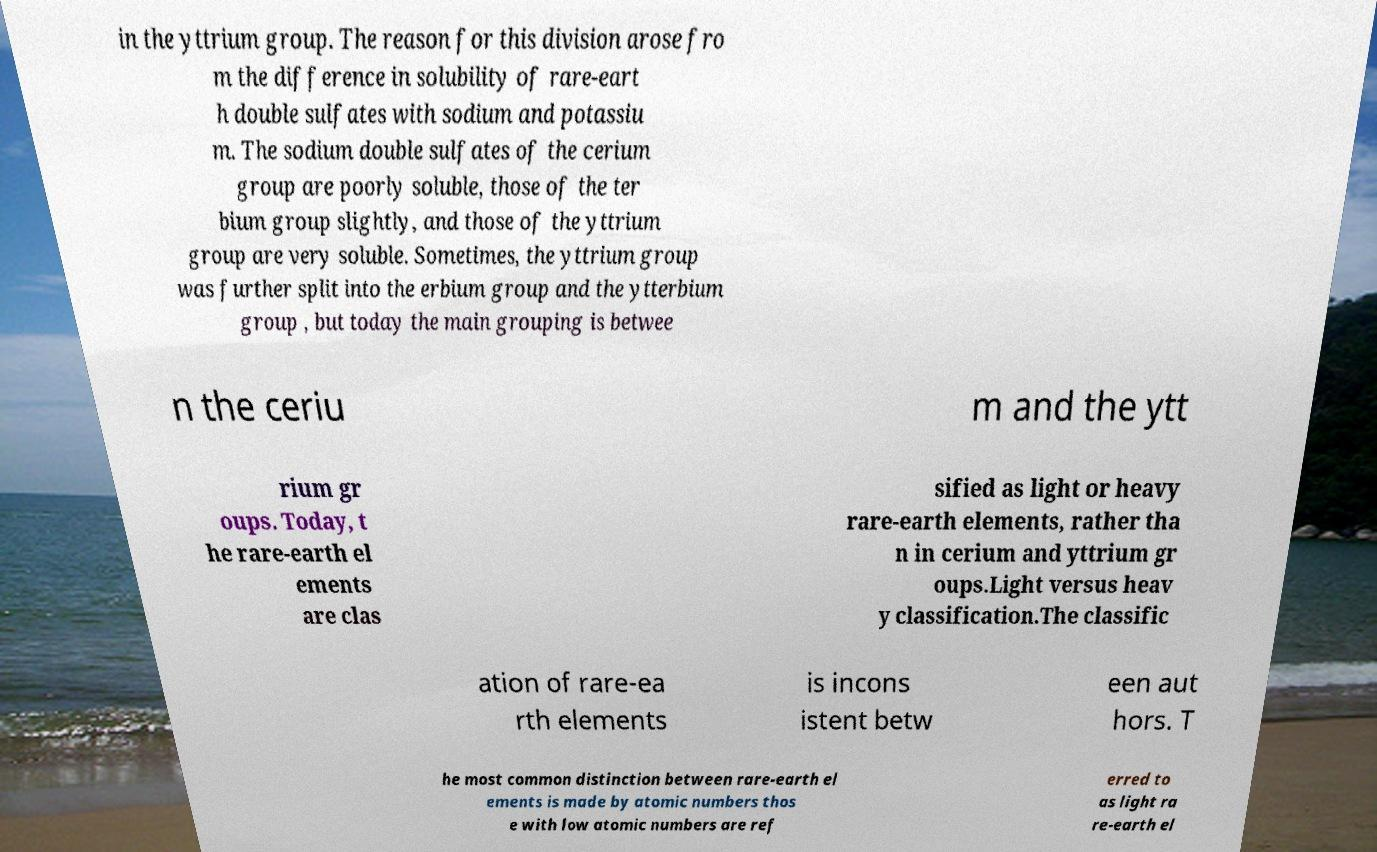Could you extract and type out the text from this image? in the yttrium group. The reason for this division arose fro m the difference in solubility of rare-eart h double sulfates with sodium and potassiu m. The sodium double sulfates of the cerium group are poorly soluble, those of the ter bium group slightly, and those of the yttrium group are very soluble. Sometimes, the yttrium group was further split into the erbium group and the ytterbium group , but today the main grouping is betwee n the ceriu m and the ytt rium gr oups. Today, t he rare-earth el ements are clas sified as light or heavy rare-earth elements, rather tha n in cerium and yttrium gr oups.Light versus heav y classification.The classific ation of rare-ea rth elements is incons istent betw een aut hors. T he most common distinction between rare-earth el ements is made by atomic numbers thos e with low atomic numbers are ref erred to as light ra re-earth el 